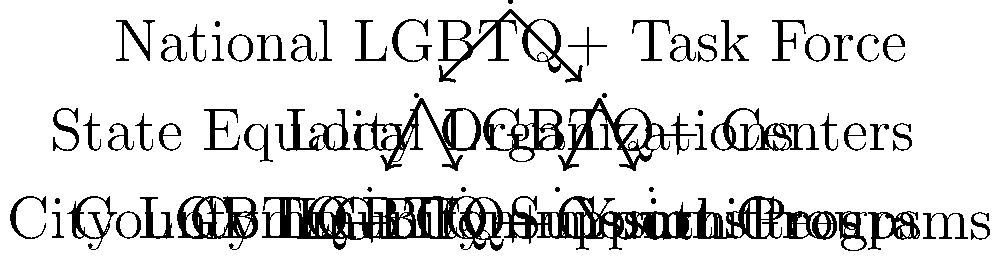Based on the hierarchical structure of LGBTQ+ organizations shown in the diagram, which entity is positioned at the top and likely has the broadest influence on LGBTQ+ policy at a national level? To answer this question, let's analyze the diagram step-by-step:

1. The diagram shows a hierarchical structure of LGBTQ+ organizations.

2. At the top of the hierarchy, we see a single entity: "National LGBTQ+ Task Force".

3. Below the National LGBTQ+ Task Force, there are two main branches:
   a. State Equality Organizations
   b. Local LGBTQ+ Centers

4. Each of these branches then has two sub-branches:
   - Under State Equality Organizations:
     a. City LGBTQ+ Commissions
     b. County LGBTQ+ Committees
   - Under Local LGBTQ+ Centers:
     a. Community Support Groups
     b. LGBTQ+ Youth Programs

5. The arrows in the diagram point downwards, indicating a top-down flow of influence or organization.

6. Given its position at the top of the hierarchy and its "National" designation, the National LGBTQ+ Task Force is likely to have the broadest influence on LGBTQ+ policy at a national level.

7. This organization's position suggests that it may set overarching goals, strategies, or policies that influence the work of organizations at lower levels in the hierarchy.

Therefore, based on the hierarchical structure presented in the diagram, the National LGBTQ+ Task Force is positioned at the top and likely has the broadest influence on LGBTQ+ policy at a national level.
Answer: National LGBTQ+ Task Force 